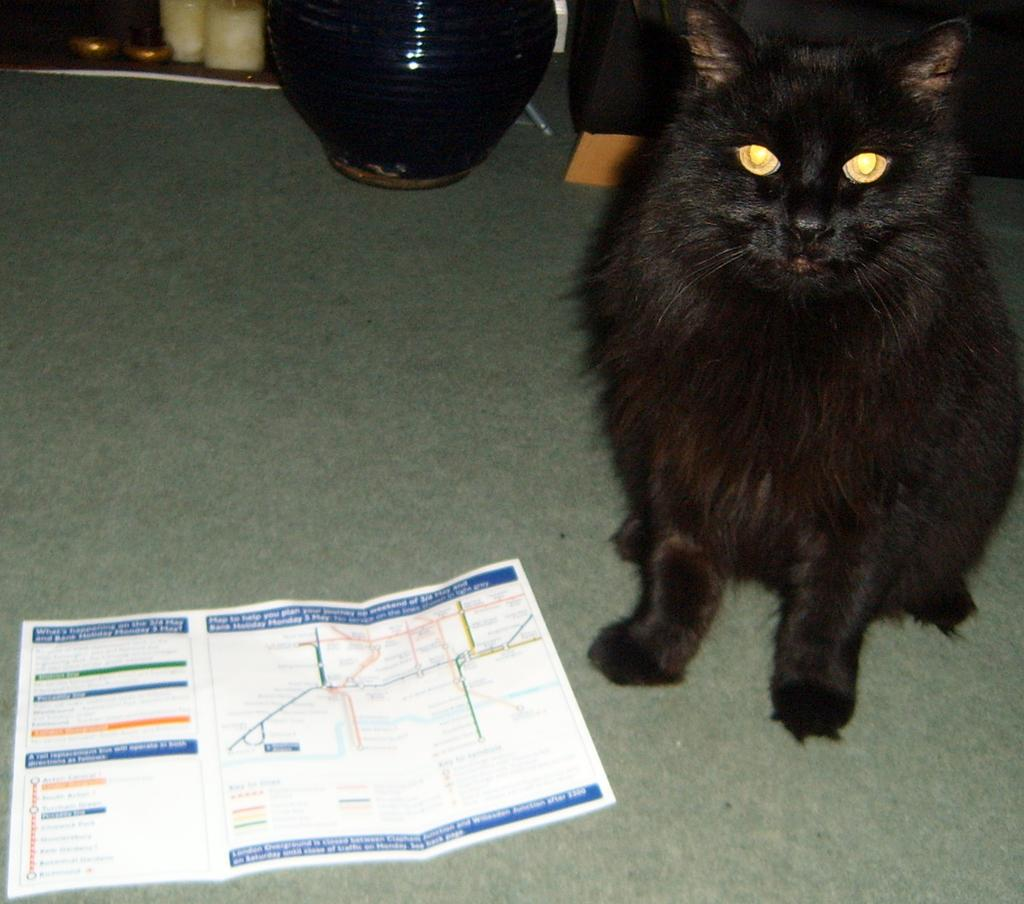What is on the floor in the image? There is a paper and a black cat sitting on the floor in the image. Can you describe the cat in the image? The cat is black and is sitting on the floor. What can be seen in the background of the image? There is a vase and other items visible in the background of the image. What type of marble is the cat playing with in the image? There is no marble present in the image; the cat is sitting on the floor next to a paper. What is the tax rate for the items visible in the image? There is no information about tax rates in the image, as it only shows a paper, a black cat, a vase, and other items in the background. 